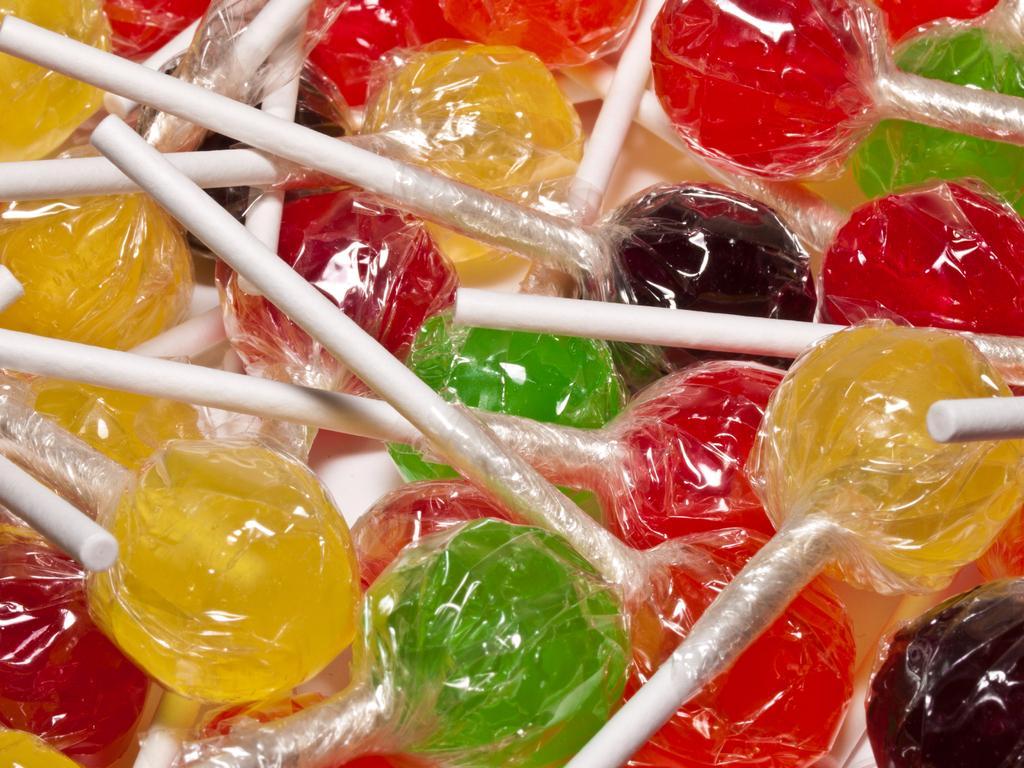Please provide a concise description of this image. In this image, I can see colorful lollipops. 